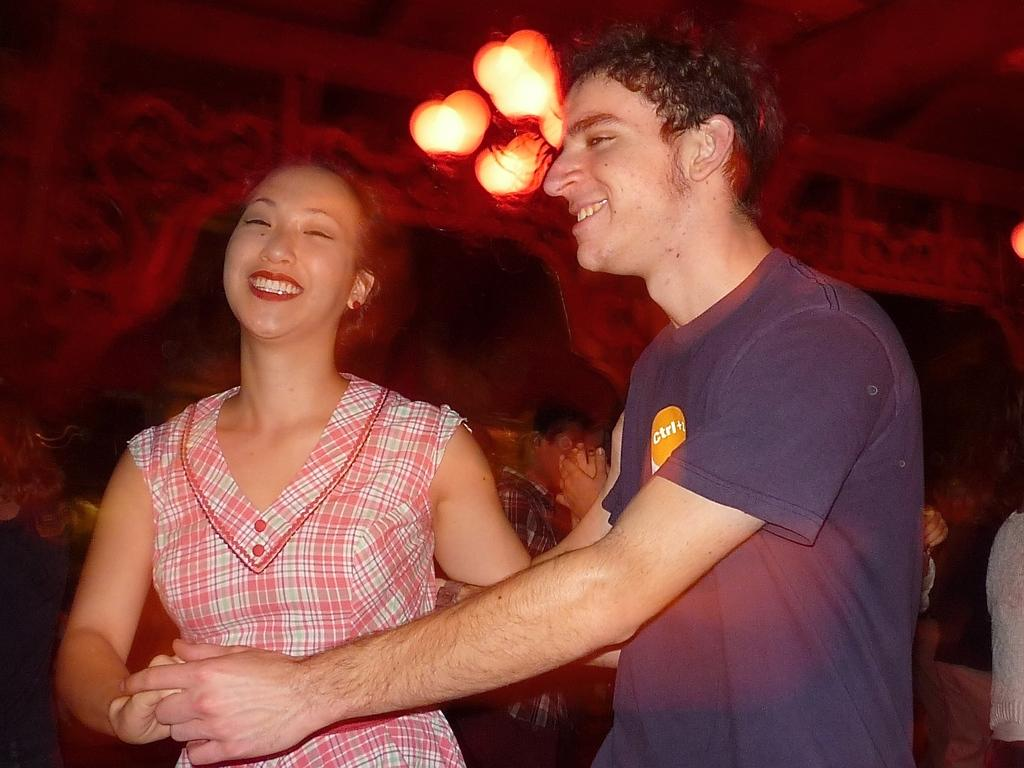What are the two persons in the image doing? The two persons in the image are holding each other. Are there any other people visible in the image? Yes, there are other persons visible in the image. What can be seen in the image that provides illumination? There are lights in the image. How many boys are playing with the flame in the image? There are no boys or flames present in the image. What type of thunder can be heard in the image? There is no thunder present in the image, as it is a still image and cannot produce sound. 